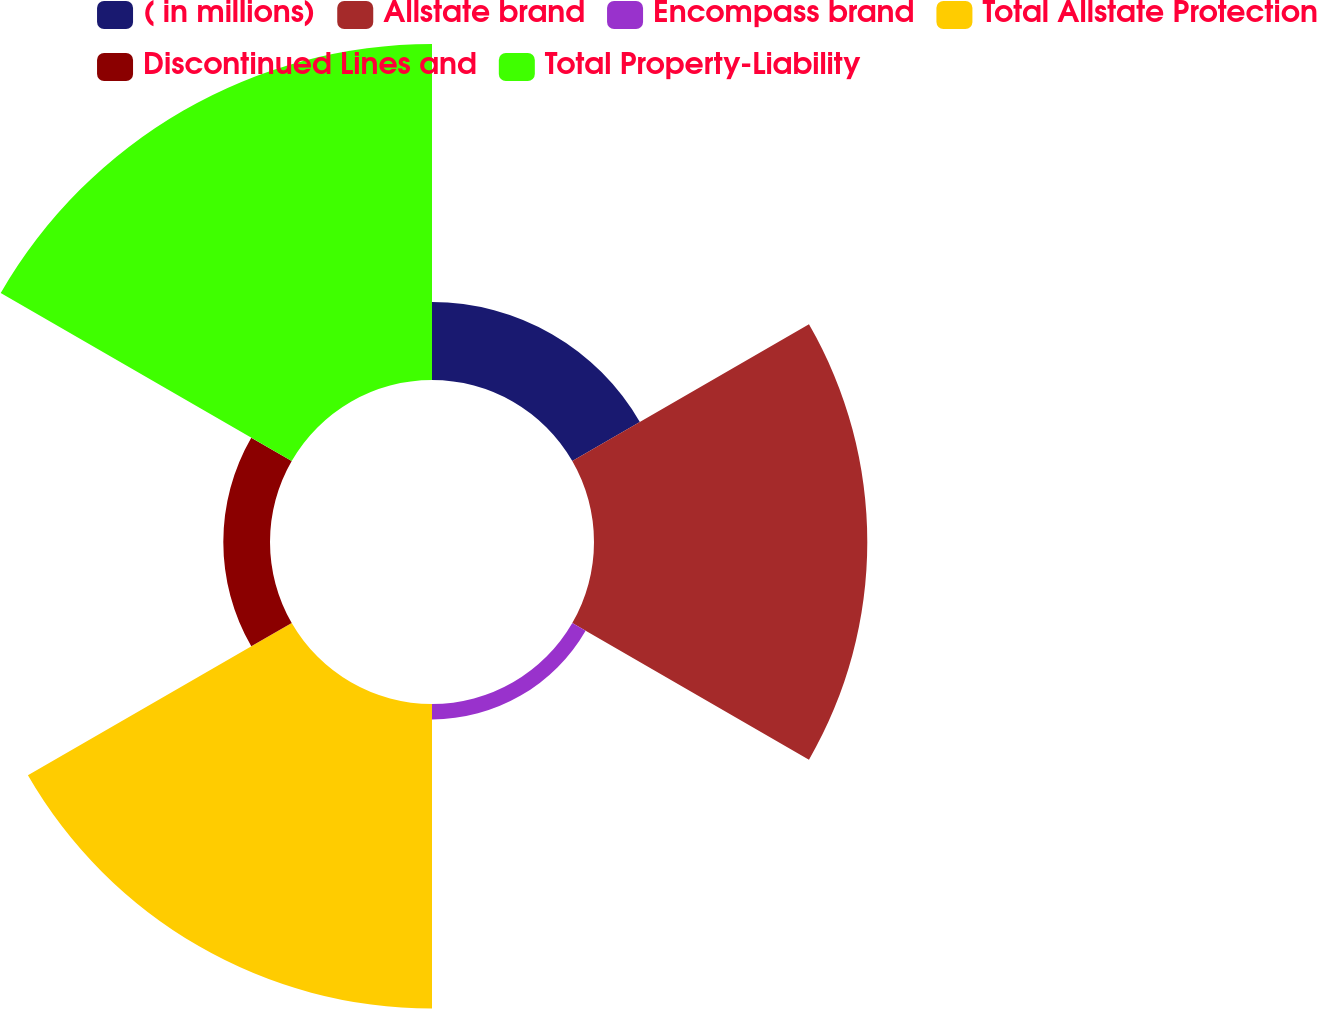Convert chart. <chart><loc_0><loc_0><loc_500><loc_500><pie_chart><fcel>( in millions)<fcel>Allstate brand<fcel>Encompass brand<fcel>Total Allstate Protection<fcel>Discontinued Lines and<fcel>Total Property-Liability<nl><fcel>7.4%<fcel>25.93%<fcel>1.46%<fcel>28.9%<fcel>4.43%<fcel>31.88%<nl></chart> 